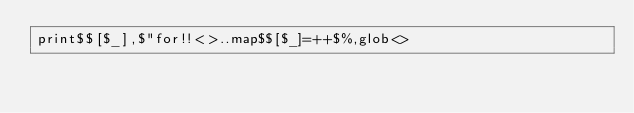<code> <loc_0><loc_0><loc_500><loc_500><_Perl_>print$$[$_],$"for!!<>..map$$[$_]=++$%,glob<></code> 